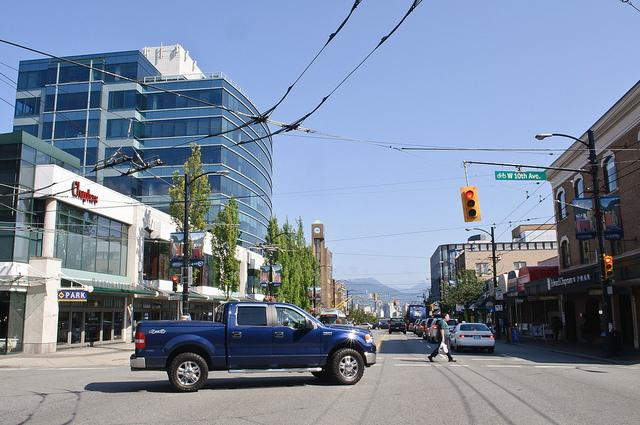What is the make of the blue pickup truck? ford 